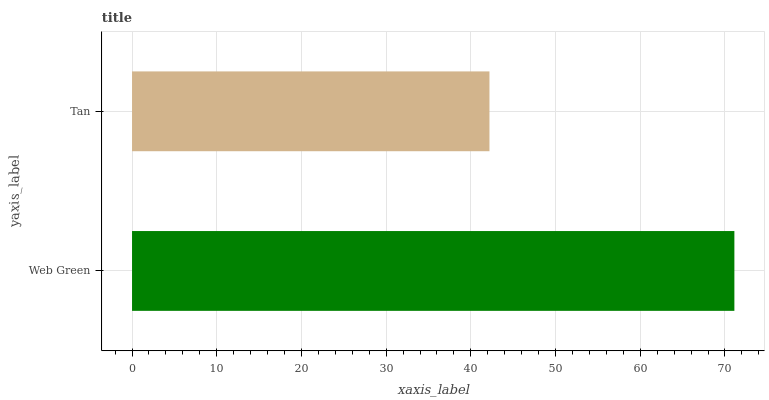Is Tan the minimum?
Answer yes or no. Yes. Is Web Green the maximum?
Answer yes or no. Yes. Is Tan the maximum?
Answer yes or no. No. Is Web Green greater than Tan?
Answer yes or no. Yes. Is Tan less than Web Green?
Answer yes or no. Yes. Is Tan greater than Web Green?
Answer yes or no. No. Is Web Green less than Tan?
Answer yes or no. No. Is Web Green the high median?
Answer yes or no. Yes. Is Tan the low median?
Answer yes or no. Yes. Is Tan the high median?
Answer yes or no. No. Is Web Green the low median?
Answer yes or no. No. 